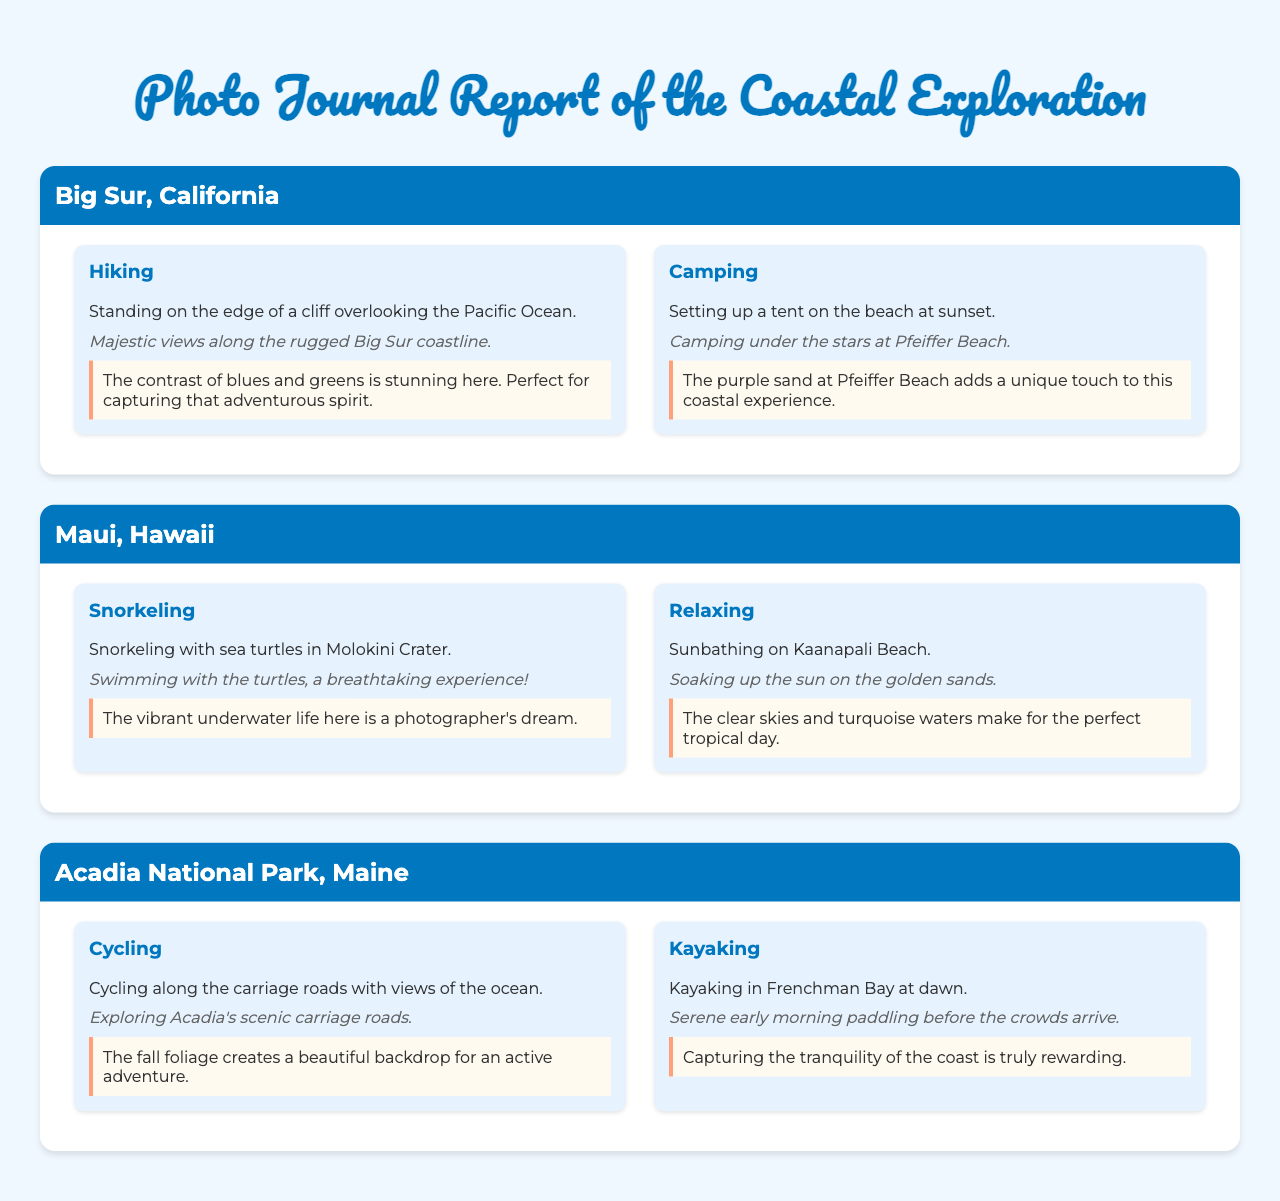What is the title of the report? The title of the report is prominently stated at the top of the document, showcasing the main theme.
Answer: Photo Journal Report of the Coastal Exploration How many locations are featured in the document? The document lists specific regions where vibrant lifestyle shots were taken, providing details for each.
Answer: Three What activity is highlighted in Big Sur, California? The document categorizes each activity, making it easy to identify the experiences associated with each location.
Answer: Hiking What is the unique feature of Pfeiffer Beach? The document notes specific details that make certain locations special, enhancing the viewer's understanding.
Answer: Purple sand In which location can you find Molokini Crater? The report specifies locations for different activities, giving readers a clear understanding of each setting.
Answer: Maui, Hawaii What type of activity is featured for Acadia National Park? The document includes various outdoor activities specific to each location, allowing for a diverse exploration experience.
Answer: Cycling What color is associated with the waters in Maui, Hawaii? The document includes descriptive captions that highlight visual aspects, contributing to the overall imagery.
Answer: Turquoise What type of shot is taken at dawn in Acadia National Park? The report provides details about the time frames for various activities, enhancing the storytelling aspect of the exploration.
Answer: Kayaking 